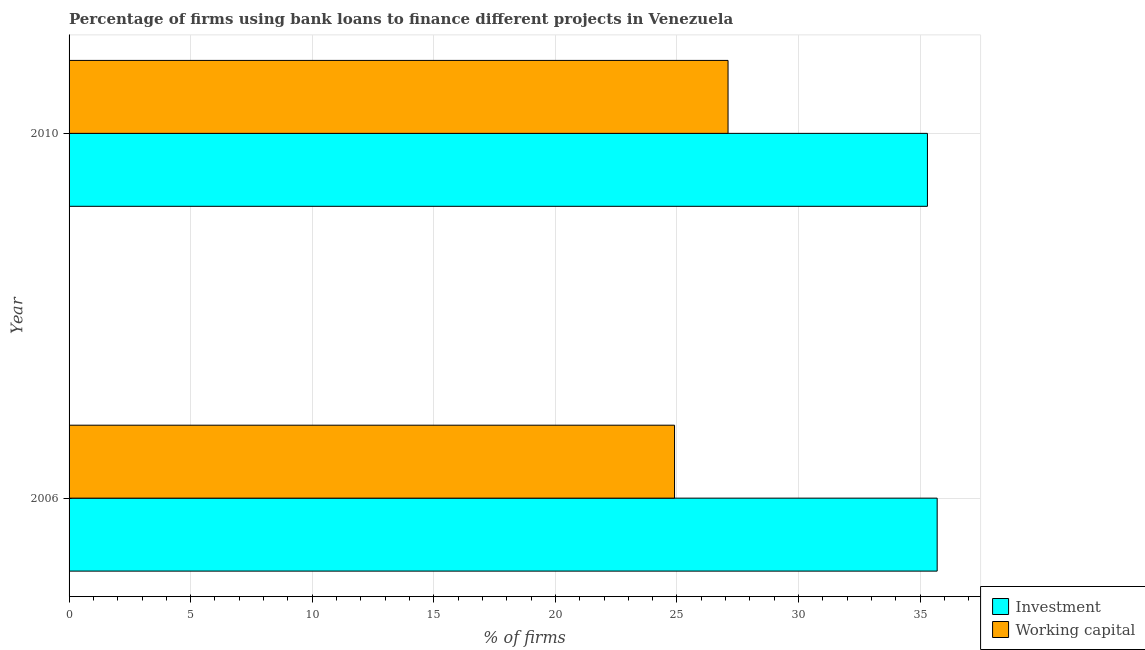How many different coloured bars are there?
Provide a short and direct response. 2. How many groups of bars are there?
Make the answer very short. 2. Are the number of bars per tick equal to the number of legend labels?
Offer a terse response. Yes. Are the number of bars on each tick of the Y-axis equal?
Ensure brevity in your answer.  Yes. How many bars are there on the 2nd tick from the top?
Offer a terse response. 2. How many bars are there on the 2nd tick from the bottom?
Keep it short and to the point. 2. What is the percentage of firms using banks to finance working capital in 2006?
Ensure brevity in your answer.  24.9. Across all years, what is the maximum percentage of firms using banks to finance investment?
Offer a terse response. 35.7. Across all years, what is the minimum percentage of firms using banks to finance working capital?
Keep it short and to the point. 24.9. In which year was the percentage of firms using banks to finance working capital minimum?
Keep it short and to the point. 2006. What is the total percentage of firms using banks to finance investment in the graph?
Ensure brevity in your answer.  71. What is the difference between the percentage of firms using banks to finance working capital in 2006 and that in 2010?
Provide a succinct answer. -2.2. What is the difference between the percentage of firms using banks to finance working capital in 2010 and the percentage of firms using banks to finance investment in 2006?
Offer a very short reply. -8.6. What is the average percentage of firms using banks to finance investment per year?
Your response must be concise. 35.5. In how many years, is the percentage of firms using banks to finance working capital greater than 14 %?
Your response must be concise. 2. What is the ratio of the percentage of firms using banks to finance working capital in 2006 to that in 2010?
Provide a succinct answer. 0.92. Is the percentage of firms using banks to finance investment in 2006 less than that in 2010?
Offer a very short reply. No. Is the difference between the percentage of firms using banks to finance investment in 2006 and 2010 greater than the difference between the percentage of firms using banks to finance working capital in 2006 and 2010?
Offer a terse response. Yes. In how many years, is the percentage of firms using banks to finance working capital greater than the average percentage of firms using banks to finance working capital taken over all years?
Offer a very short reply. 1. What does the 1st bar from the top in 2010 represents?
Your response must be concise. Working capital. What does the 1st bar from the bottom in 2010 represents?
Your answer should be compact. Investment. How many years are there in the graph?
Make the answer very short. 2. Does the graph contain any zero values?
Provide a short and direct response. No. Where does the legend appear in the graph?
Offer a terse response. Bottom right. How are the legend labels stacked?
Provide a succinct answer. Vertical. What is the title of the graph?
Your response must be concise. Percentage of firms using bank loans to finance different projects in Venezuela. Does "2012 US$" appear as one of the legend labels in the graph?
Give a very brief answer. No. What is the label or title of the X-axis?
Your answer should be compact. % of firms. What is the % of firms of Investment in 2006?
Provide a short and direct response. 35.7. What is the % of firms in Working capital in 2006?
Provide a succinct answer. 24.9. What is the % of firms in Investment in 2010?
Make the answer very short. 35.3. What is the % of firms in Working capital in 2010?
Your response must be concise. 27.1. Across all years, what is the maximum % of firms of Investment?
Give a very brief answer. 35.7. Across all years, what is the maximum % of firms in Working capital?
Make the answer very short. 27.1. Across all years, what is the minimum % of firms of Investment?
Make the answer very short. 35.3. Across all years, what is the minimum % of firms in Working capital?
Provide a succinct answer. 24.9. What is the difference between the % of firms of Investment in 2006 and that in 2010?
Your answer should be very brief. 0.4. What is the difference between the % of firms of Working capital in 2006 and that in 2010?
Provide a succinct answer. -2.2. What is the difference between the % of firms in Investment in 2006 and the % of firms in Working capital in 2010?
Your answer should be very brief. 8.6. What is the average % of firms in Investment per year?
Keep it short and to the point. 35.5. What is the average % of firms in Working capital per year?
Provide a succinct answer. 26. What is the ratio of the % of firms of Investment in 2006 to that in 2010?
Offer a terse response. 1.01. What is the ratio of the % of firms of Working capital in 2006 to that in 2010?
Offer a terse response. 0.92. What is the difference between the highest and the second highest % of firms in Investment?
Your answer should be compact. 0.4. What is the difference between the highest and the second highest % of firms in Working capital?
Your answer should be very brief. 2.2. 